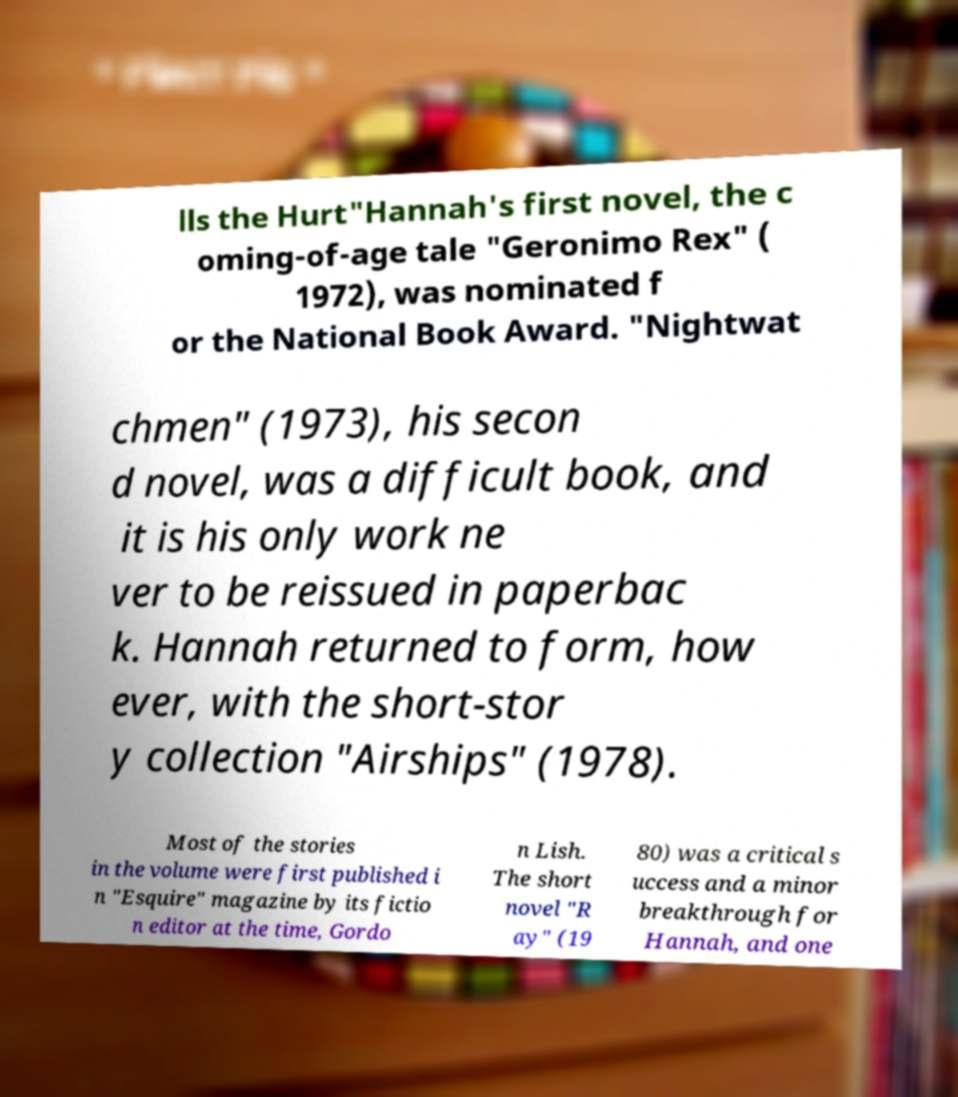Please read and relay the text visible in this image. What does it say? lls the Hurt"Hannah's first novel, the c oming-of-age tale "Geronimo Rex" ( 1972), was nominated f or the National Book Award. "Nightwat chmen" (1973), his secon d novel, was a difficult book, and it is his only work ne ver to be reissued in paperbac k. Hannah returned to form, how ever, with the short-stor y collection "Airships" (1978). Most of the stories in the volume were first published i n "Esquire" magazine by its fictio n editor at the time, Gordo n Lish. The short novel "R ay" (19 80) was a critical s uccess and a minor breakthrough for Hannah, and one 